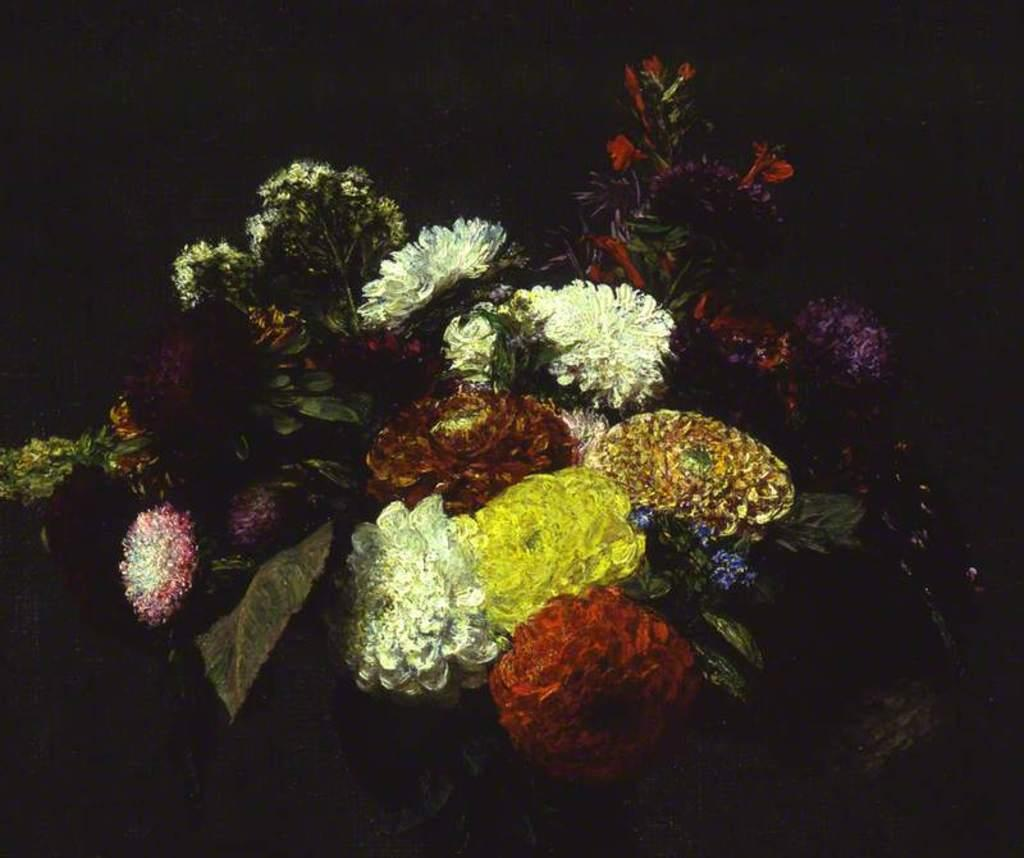What type of living organisms can be seen in the image? Flowers can be seen in the image. What type of farmer is taking care of the flowers in the image? There is no farmer present in the image, as it only features flowers. 